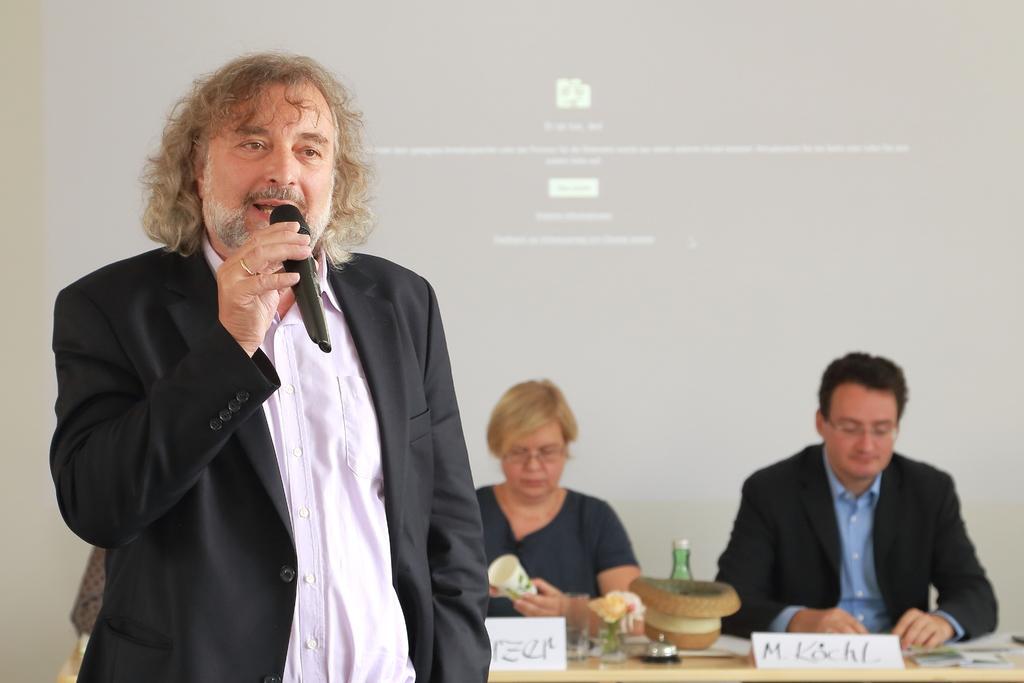Could you give a brief overview of what you see in this image? In this picture we can see a man who is talking on the mike. He is in black color suit. And here we can see two persons sitting on the chairs. This is the table. On the background there is a screen. 